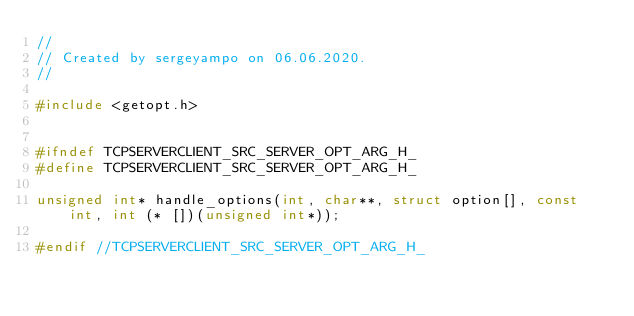Convert code to text. <code><loc_0><loc_0><loc_500><loc_500><_C_>//
// Created by sergeyampo on 06.06.2020.
//

#include <getopt.h>


#ifndef TCPSERVERCLIENT_SRC_SERVER_OPT_ARG_H_
#define TCPSERVERCLIENT_SRC_SERVER_OPT_ARG_H_

unsigned int* handle_options(int, char**, struct option[], const int, int (* [])(unsigned int*));

#endif //TCPSERVERCLIENT_SRC_SERVER_OPT_ARG_H_</code> 